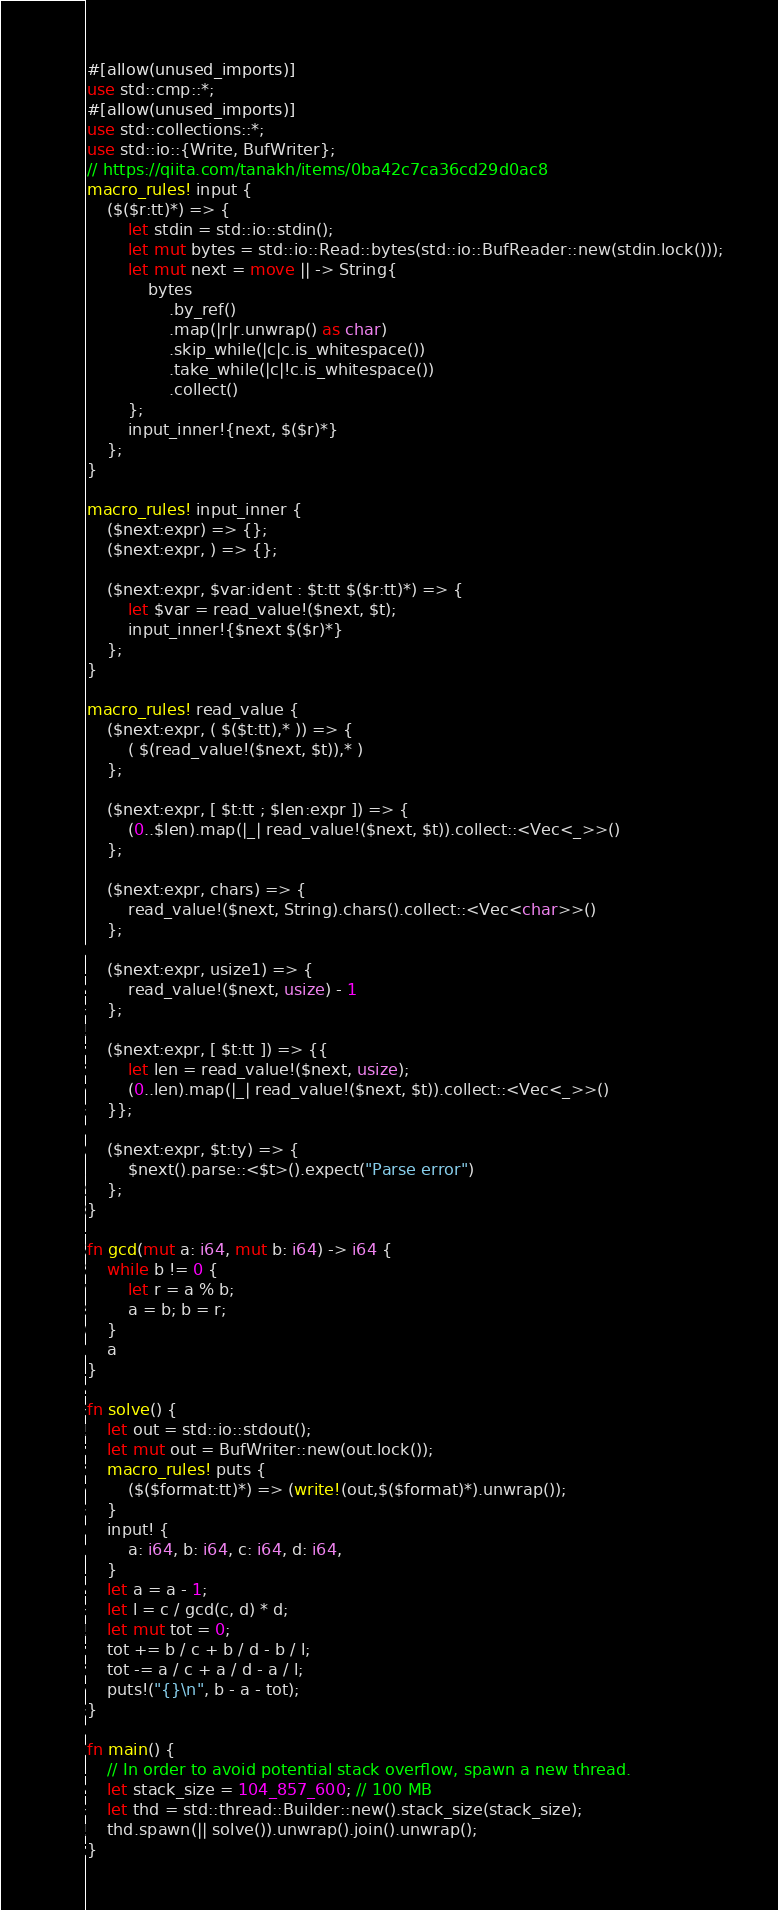<code> <loc_0><loc_0><loc_500><loc_500><_Rust_>#[allow(unused_imports)]
use std::cmp::*;
#[allow(unused_imports)]
use std::collections::*;
use std::io::{Write, BufWriter};
// https://qiita.com/tanakh/items/0ba42c7ca36cd29d0ac8
macro_rules! input {
    ($($r:tt)*) => {
        let stdin = std::io::stdin();
        let mut bytes = std::io::Read::bytes(std::io::BufReader::new(stdin.lock()));
        let mut next = move || -> String{
            bytes
                .by_ref()
                .map(|r|r.unwrap() as char)
                .skip_while(|c|c.is_whitespace())
                .take_while(|c|!c.is_whitespace())
                .collect()
        };
        input_inner!{next, $($r)*}
    };
}

macro_rules! input_inner {
    ($next:expr) => {};
    ($next:expr, ) => {};

    ($next:expr, $var:ident : $t:tt $($r:tt)*) => {
        let $var = read_value!($next, $t);
        input_inner!{$next $($r)*}
    };
}

macro_rules! read_value {
    ($next:expr, ( $($t:tt),* )) => {
        ( $(read_value!($next, $t)),* )
    };

    ($next:expr, [ $t:tt ; $len:expr ]) => {
        (0..$len).map(|_| read_value!($next, $t)).collect::<Vec<_>>()
    };

    ($next:expr, chars) => {
        read_value!($next, String).chars().collect::<Vec<char>>()
    };

    ($next:expr, usize1) => {
        read_value!($next, usize) - 1
    };

    ($next:expr, [ $t:tt ]) => {{
        let len = read_value!($next, usize);
        (0..len).map(|_| read_value!($next, $t)).collect::<Vec<_>>()
    }};

    ($next:expr, $t:ty) => {
        $next().parse::<$t>().expect("Parse error")
    };
}

fn gcd(mut a: i64, mut b: i64) -> i64 {
    while b != 0 {
        let r = a % b;
        a = b; b = r;
    }
    a
}

fn solve() {
    let out = std::io::stdout();
    let mut out = BufWriter::new(out.lock());
    macro_rules! puts {
        ($($format:tt)*) => (write!(out,$($format)*).unwrap());
    }
    input! {
        a: i64, b: i64, c: i64, d: i64,
    }
    let a = a - 1;
    let l = c / gcd(c, d) * d;
    let mut tot = 0;
    tot += b / c + b / d - b / l;
    tot -= a / c + a / d - a / l;
    puts!("{}\n", b - a - tot);
}

fn main() {
    // In order to avoid potential stack overflow, spawn a new thread.
    let stack_size = 104_857_600; // 100 MB
    let thd = std::thread::Builder::new().stack_size(stack_size);
    thd.spawn(|| solve()).unwrap().join().unwrap();
}
</code> 